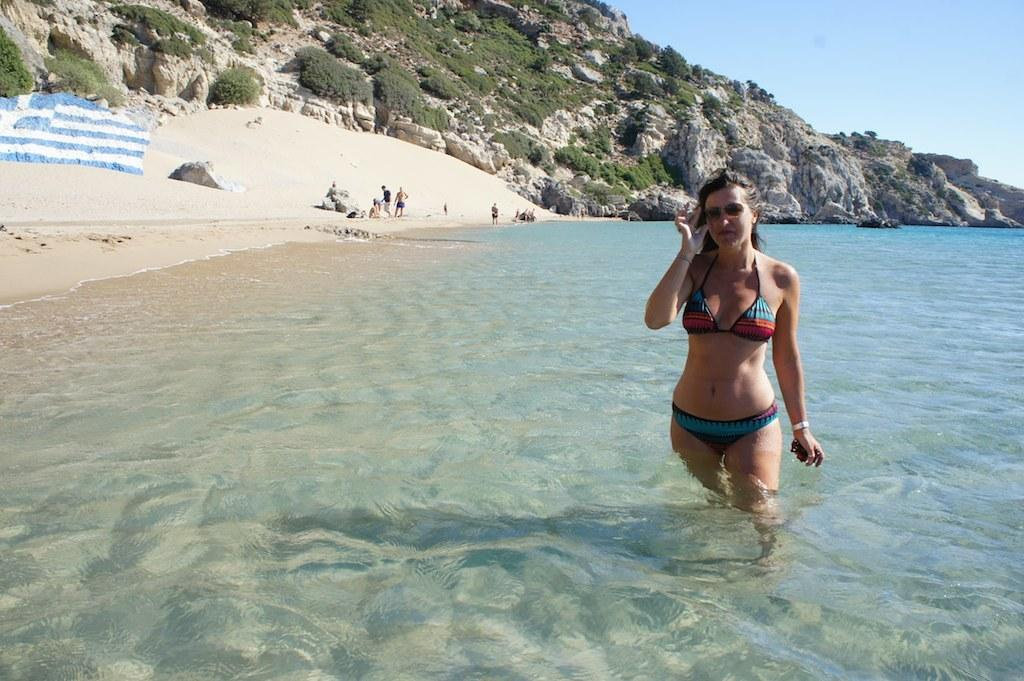What is the woman in the image doing? The woman is in the water. What can be seen in the background of the image? There is a hill, trees, and the sky visible in the background of the image. How many fangs does the ladybug have in the image? There is no ladybug present in the image, so it is not possible to determine how many fangs it might have. 